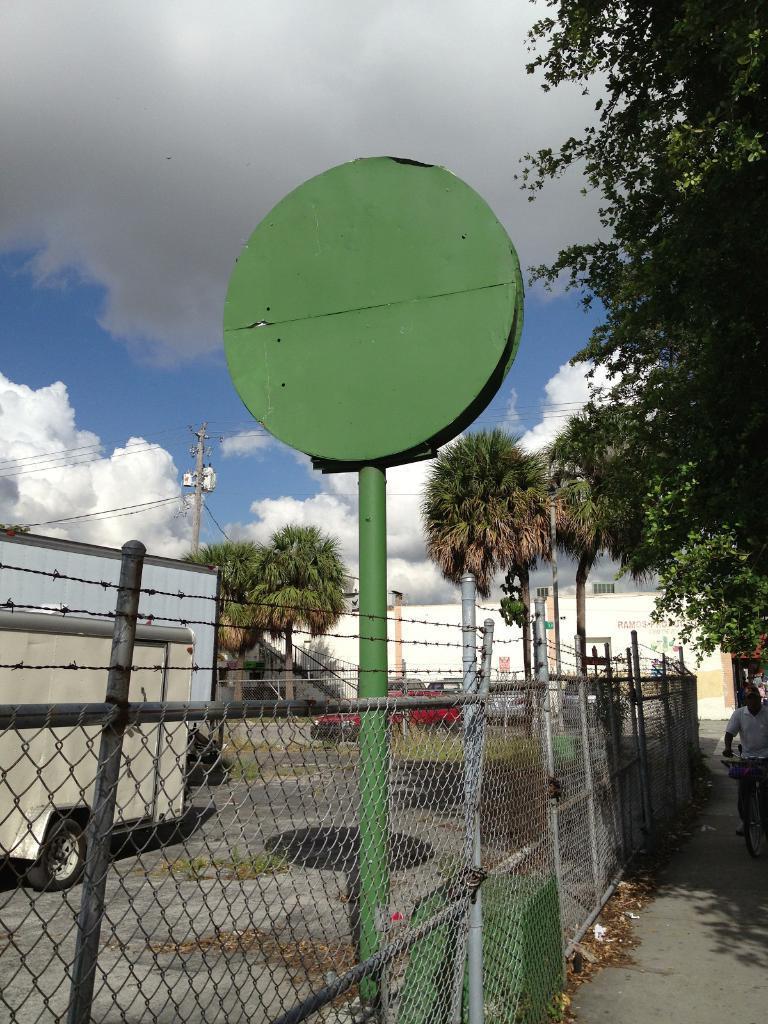Can you describe this image briefly? In this picture we can see a fence, poles, dry leaves and a board on the pole. We can see a vehicles on the road. There are a few trees and a building in the background. Sky is blue in color and cloudy. 